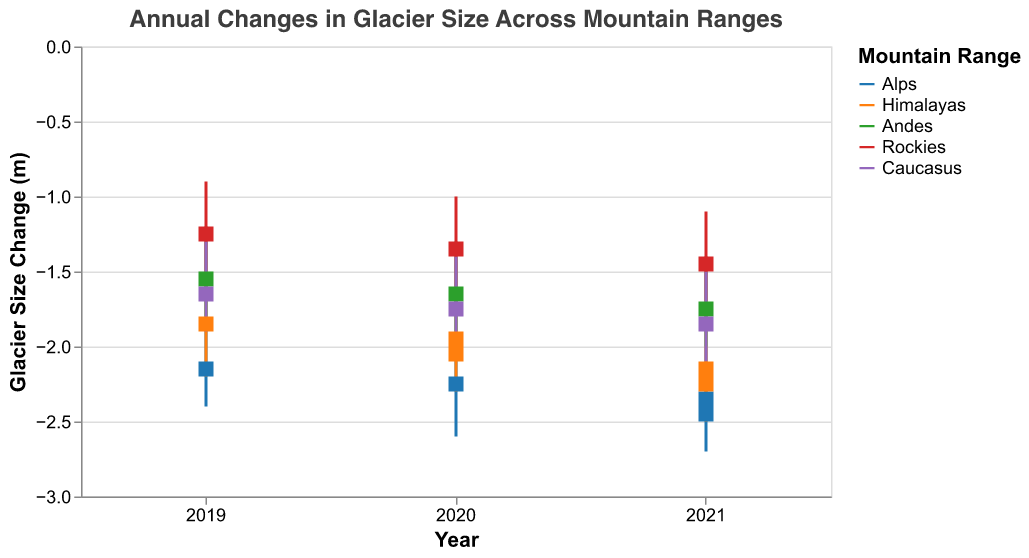what is the title of the figure? The title of the figure is at the top of the chart, which states clearly, "Annual Changes in Glacier Size Across Mountain Ranges"
Answer: Annual Changes in Glacier Size Across Mountain Ranges Which mountain range showed the highest 'High' value in 2021? The highest 'High' value in 2021 can be found by comparing the 'High' values of all mountain ranges for that year. Alps has the highest 'High' value at -2.0 meters
Answer: Alps How did the glacier size in the Alps change from 2020 to 2021? In 2020, the 'Open' was -2.2 and 'Close' was -2.3. In 2021, the 'Open' was -2.3 and 'Close' was -2.5. This indicates the glacier size in the Alps decreased by 0.2 meters from 2020 to 2021
Answer: Decreased by 0.2 meters Compare the range of glacier size changes (High - Low) for the Rockies in 2019 and 2021? In 2019, the Rockies had 'High' of -0.9 and 'Low' of -1.5, so the range is -0.9 - (-1.5) = 0.6. In 2021, the Rockies had 'High' of -1.1 and 'Low' of -1.7, so the range is -1.1 - (-1.7) = 0.6. The ranges are equal in both years.
Answer: 0.6 in both years Which mountain range had the smallest glacier size change (Close - Open) in 2020? By comparing the 'Close - Open' values for all mountain ranges in 2020: Alps (-2.3 - -2.2 = -0.1), Himalayas (-2.1 - -1.9 = -0.2), Andes (-1.7 - -1.6 = -0.1), Rockies (-1.4 - -1.3 = -0.1), and Caucasus (-1.8 - -1.7 = -0.1), we find the smallest change is -0.1 meters shown in Alps, Andes, Rockies, and Caucasus
Answer: Alps, Andes, Rockies, and Caucasus What is the average 'Close' value for the Caucasus from 2019 to 2021? Calculate the average 'Close' value for Caucasus: (2019: -1.7, 2020: -1.8, 2021: -1.9). The sum is -1.7 + -1.8 + -1.9 = -5.4. The average is -5.4 / 3 = -1.8
Answer: -1.8 What is the overall trend of glacier size in the Himalayas from 2019 to 2021? For the Himalayas, 'Open' values were: 2019 (-1.8), 2020 (-1.9), 2021 (-2.1); 'Close' values were: 2019 (-1.9), 2020 (-2.1), 2021 (-2.3). Both 'Open' and 'Close' values are decreasing over the three years, indicating a general trend of glacier size reduction
Answer: Decreasing How does the 'Low' value in Andes for 2021 compare with the 'Low' value in the Rockies for the same year? The 'Low' value for the Andes in 2021 is -2.0 and for the Rockies in 2021 is -1.7. The Andes has a lower 'Low' value compared to the Rockies
Answer: Andes has a lower Low value Which mountain range had the smallest overall change (High - Low) in glacier size in 2019? Compare the range (High - Low) for each mountain range in 2019: Alps (-1.8 - -2.4 = 0.6), Himalayas (-1.5 - -2.2 = 0.7), Andes (-1.2 - -1.8 = 0.6), Rockies (-0.9 - -1.5 = 0.6), and Caucasus (-1.3 - -1.9 = 0.6). The smallest change is 0.6, shared by Alps, Andes, Rockies, and Caucasus
Answer: Alps, Andes, Rockies, and Caucasus 